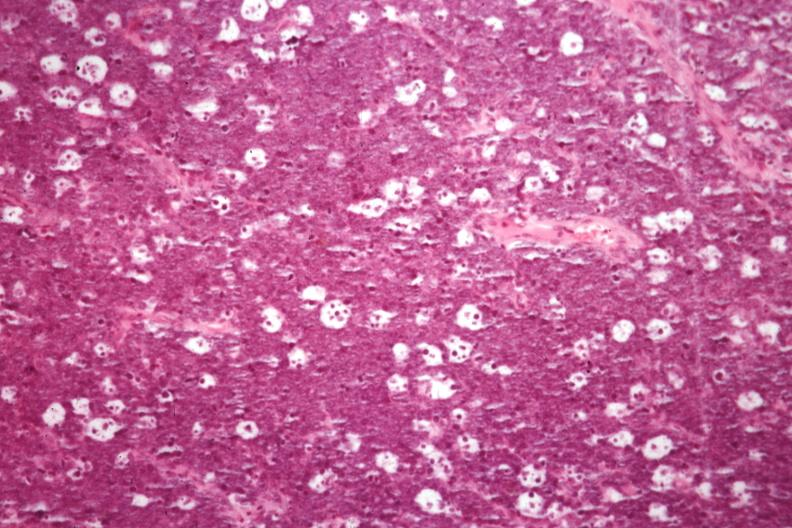what does this image show?
Answer the question using a single word or phrase. Excellent for starry sky appearance but not the best histology source 